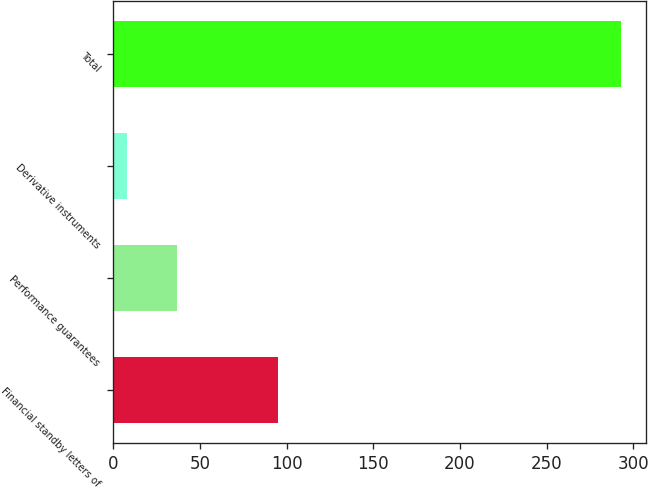<chart> <loc_0><loc_0><loc_500><loc_500><bar_chart><fcel>Financial standby letters of<fcel>Performance guarantees<fcel>Derivative instruments<fcel>Total<nl><fcel>94.8<fcel>36.55<fcel>8.1<fcel>292.6<nl></chart> 